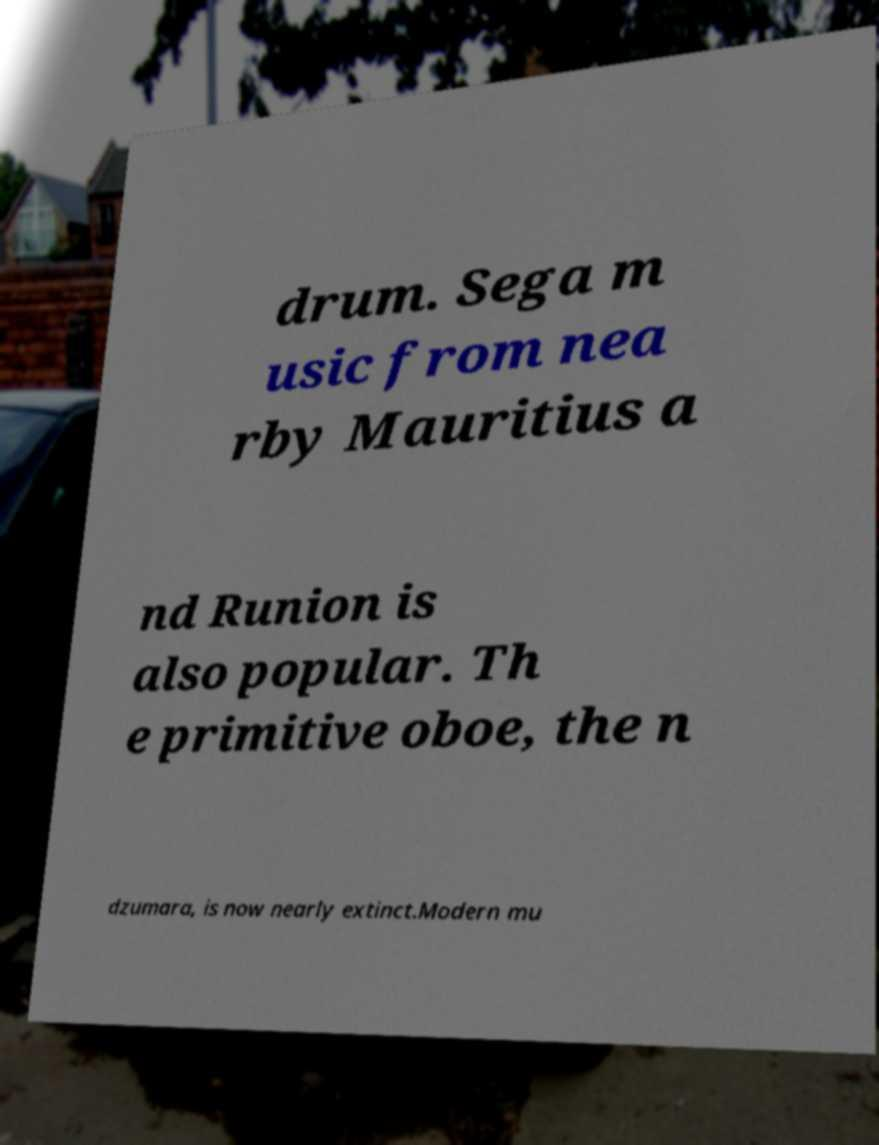There's text embedded in this image that I need extracted. Can you transcribe it verbatim? drum. Sega m usic from nea rby Mauritius a nd Runion is also popular. Th e primitive oboe, the n dzumara, is now nearly extinct.Modern mu 